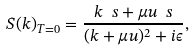<formula> <loc_0><loc_0><loc_500><loc_500>S ( k ) _ { T = 0 } = \frac { k \ s + \mu u \ s } { ( k + \mu u ) ^ { 2 } + i \epsilon } ,</formula> 